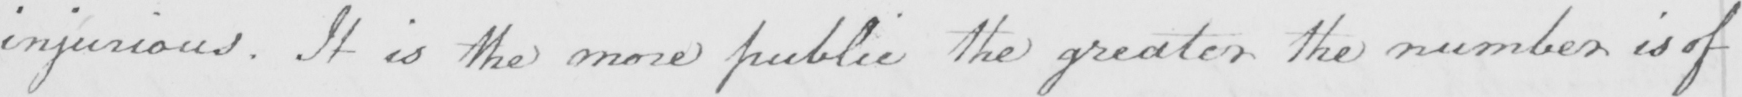Transcribe the text shown in this historical manuscript line. injurious . It is the more public the greater the number is of 